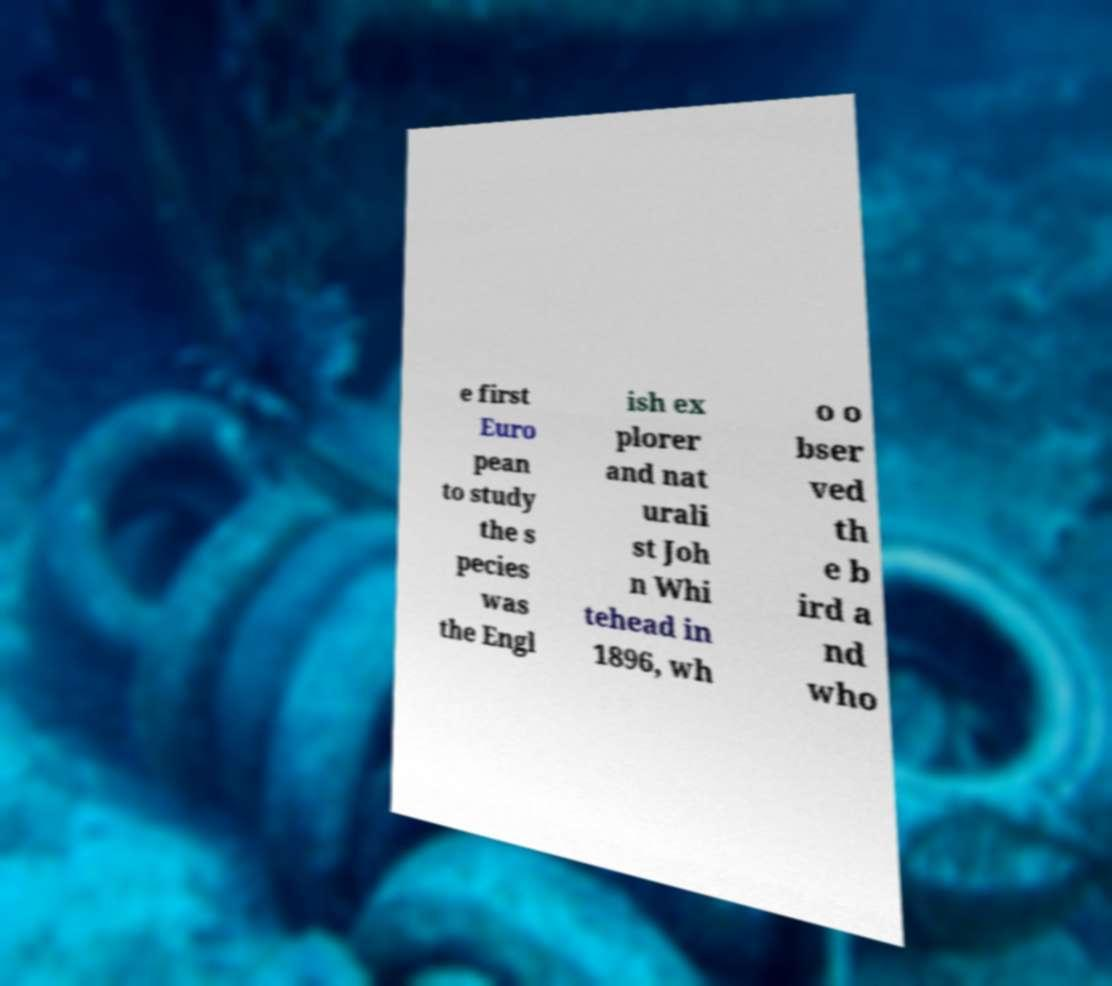Please read and relay the text visible in this image. What does it say? e first Euro pean to study the s pecies was the Engl ish ex plorer and nat urali st Joh n Whi tehead in 1896, wh o o bser ved th e b ird a nd who 